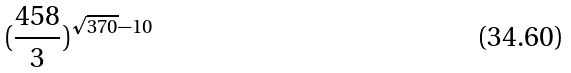<formula> <loc_0><loc_0><loc_500><loc_500>( \frac { 4 5 8 } { 3 } ) ^ { \sqrt { 3 7 0 } - 1 0 }</formula> 